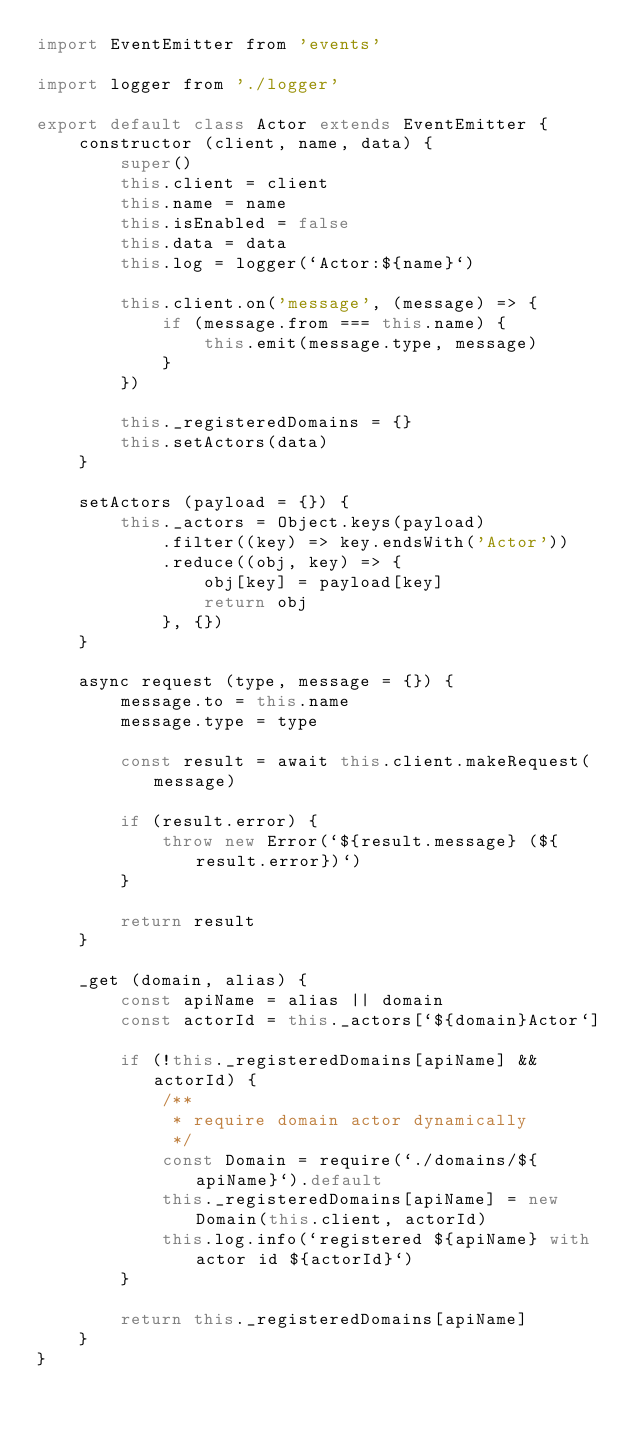Convert code to text. <code><loc_0><loc_0><loc_500><loc_500><_JavaScript_>import EventEmitter from 'events'

import logger from './logger'

export default class Actor extends EventEmitter {
    constructor (client, name, data) {
        super()
        this.client = client
        this.name = name
        this.isEnabled = false
        this.data = data
        this.log = logger(`Actor:${name}`)

        this.client.on('message', (message) => {
            if (message.from === this.name) {
                this.emit(message.type, message)
            }
        })

        this._registeredDomains = {}
        this.setActors(data)
    }

    setActors (payload = {}) {
        this._actors = Object.keys(payload)
            .filter((key) => key.endsWith('Actor'))
            .reduce((obj, key) => {
                obj[key] = payload[key]
                return obj
            }, {})
    }

    async request (type, message = {}) {
        message.to = this.name
        message.type = type

        const result = await this.client.makeRequest(message)

        if (result.error) {
            throw new Error(`${result.message} (${result.error})`)
        }

        return result
    }

    _get (domain, alias) {
        const apiName = alias || domain
        const actorId = this._actors[`${domain}Actor`]

        if (!this._registeredDomains[apiName] && actorId) {
            /**
             * require domain actor dynamically
             */
            const Domain = require(`./domains/${apiName}`).default
            this._registeredDomains[apiName] = new Domain(this.client, actorId)
            this.log.info(`registered ${apiName} with actor id ${actorId}`)
        }

        return this._registeredDomains[apiName]
    }
}
</code> 